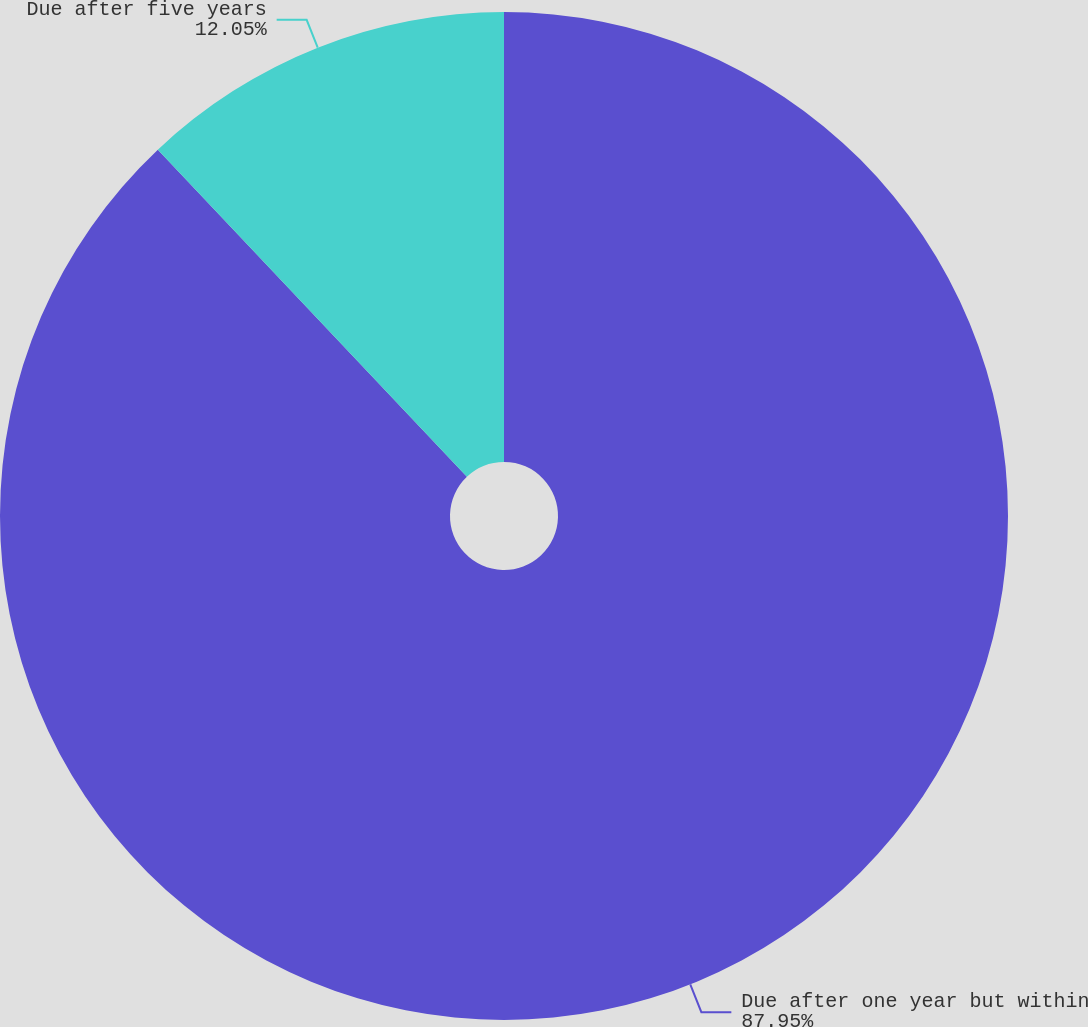Convert chart. <chart><loc_0><loc_0><loc_500><loc_500><pie_chart><fcel>Due after one year but within<fcel>Due after five years<nl><fcel>87.95%<fcel>12.05%<nl></chart> 